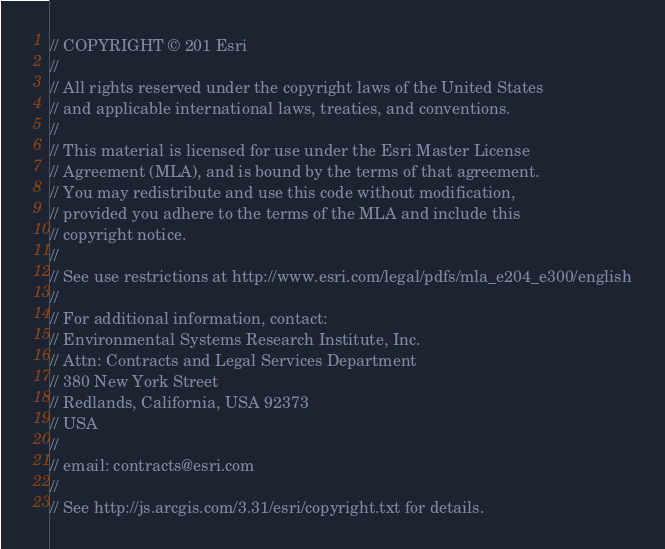<code> <loc_0><loc_0><loc_500><loc_500><_JavaScript_>// COPYRIGHT © 201 Esri
//
// All rights reserved under the copyright laws of the United States
// and applicable international laws, treaties, and conventions.
//
// This material is licensed for use under the Esri Master License
// Agreement (MLA), and is bound by the terms of that agreement.
// You may redistribute and use this code without modification,
// provided you adhere to the terms of the MLA and include this
// copyright notice.
//
// See use restrictions at http://www.esri.com/legal/pdfs/mla_e204_e300/english
//
// For additional information, contact:
// Environmental Systems Research Institute, Inc.
// Attn: Contracts and Legal Services Department
// 380 New York Street
// Redlands, California, USA 92373
// USA
//
// email: contracts@esri.com
//
// See http://js.arcgis.com/3.31/esri/copyright.txt for details.
</code> 